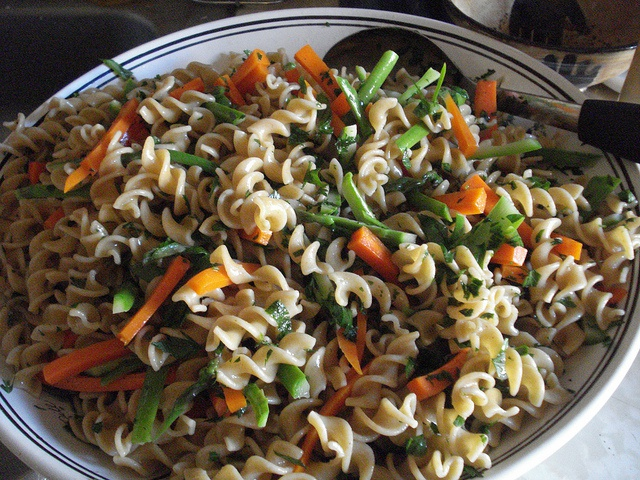Describe the objects in this image and their specific colors. I can see bowl in black, maroon, olive, and gray tones, spoon in black, gray, maroon, and darkgreen tones, carrot in black, maroon, and brown tones, carrot in black and maroon tones, and broccoli in black, darkgreen, and olive tones in this image. 